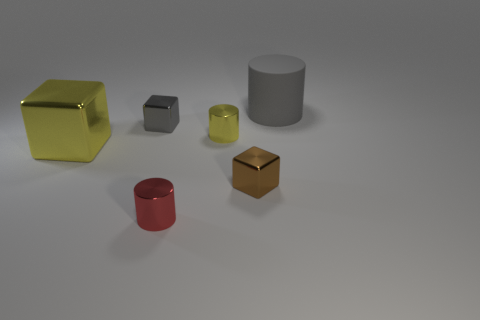Is the large object that is on the right side of the brown block made of the same material as the tiny red thing? While the large grey cylinder and the small red cylinder seem to share a similar matte finish, suggesting the possibility of being made from the same material, it's not possible to confirm material composition solely based on this image. Differences in color and size also make a definitive answer challenging without additional information. 